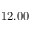Convert formula to latex. <formula><loc_0><loc_0><loc_500><loc_500>1 2 . 0 0</formula> 